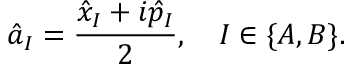Convert formula to latex. <formula><loc_0><loc_0><loc_500><loc_500>\hat { a } _ { I } = \frac { \hat { x } _ { I } + i \hat { p } _ { I } } { 2 } , \quad I \in \{ A , B \} .</formula> 